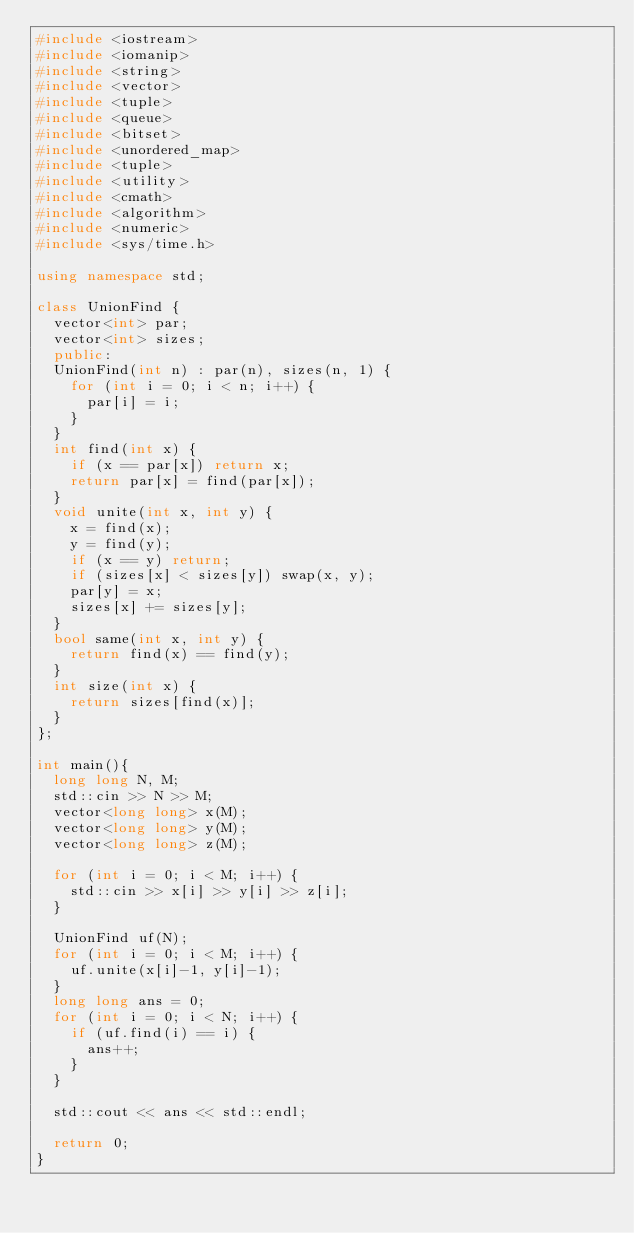Convert code to text. <code><loc_0><loc_0><loc_500><loc_500><_C++_>#include <iostream>
#include <iomanip>
#include <string>
#include <vector>
#include <tuple>
#include <queue>
#include <bitset>
#include <unordered_map>
#include <tuple>
#include <utility>
#include <cmath>
#include <algorithm>
#include <numeric>
#include <sys/time.h>

using namespace std;

class UnionFind {
  vector<int> par;
  vector<int> sizes;
  public:
  UnionFind(int n) : par(n), sizes(n, 1) {
    for (int i = 0; i < n; i++) {
      par[i] = i;
    }
  }
  int find(int x) {
    if (x == par[x]) return x;
    return par[x] = find(par[x]);
  }
  void unite(int x, int y) {
    x = find(x);
    y = find(y);
    if (x == y) return;
    if (sizes[x] < sizes[y]) swap(x, y);
    par[y] = x;
    sizes[x] += sizes[y];
  }
  bool same(int x, int y) {
    return find(x) == find(y);
  }
  int size(int x) {
    return sizes[find(x)];
  }
};

int main(){
  long long N, M;
  std::cin >> N >> M;
  vector<long long> x(M);
  vector<long long> y(M);
  vector<long long> z(M);

  for (int i = 0; i < M; i++) {
    std::cin >> x[i] >> y[i] >> z[i];
  }

  UnionFind uf(N);
  for (int i = 0; i < M; i++) {
    uf.unite(x[i]-1, y[i]-1);
  }
  long long ans = 0;
  for (int i = 0; i < N; i++) {
    if (uf.find(i) == i) {
      ans++;
    }
  }

  std::cout << ans << std::endl;

  return 0;
}
</code> 